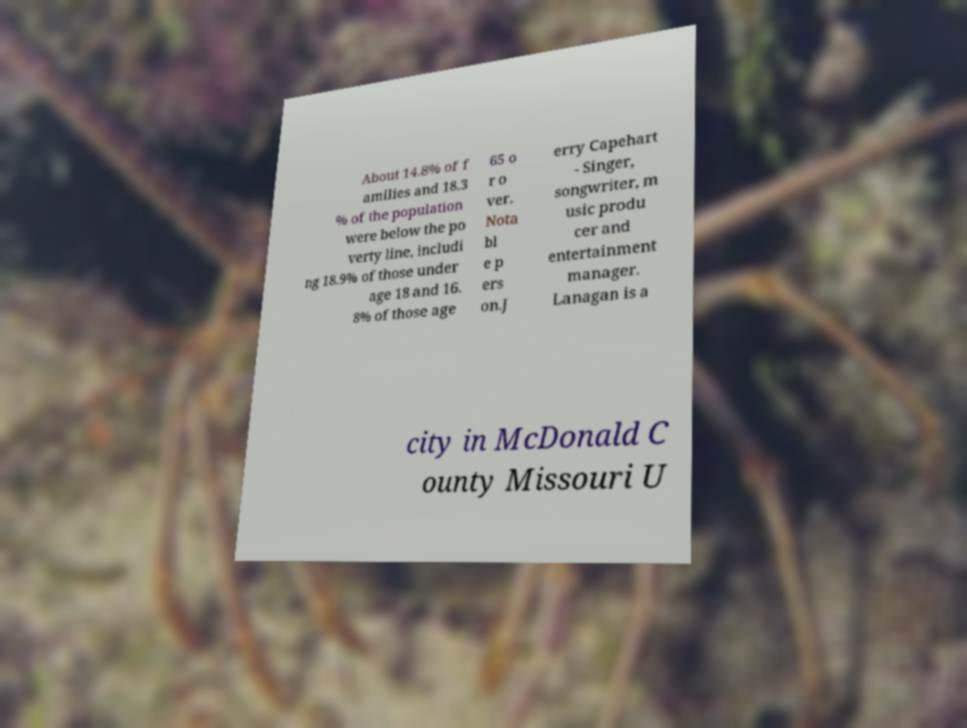Please identify and transcribe the text found in this image. About 14.8% of f amilies and 18.3 % of the population were below the po verty line, includi ng 18.9% of those under age 18 and 16. 8% of those age 65 o r o ver. Nota bl e p ers on.J erry Capehart - Singer, songwriter, m usic produ cer and entertainment manager. Lanagan is a city in McDonald C ounty Missouri U 